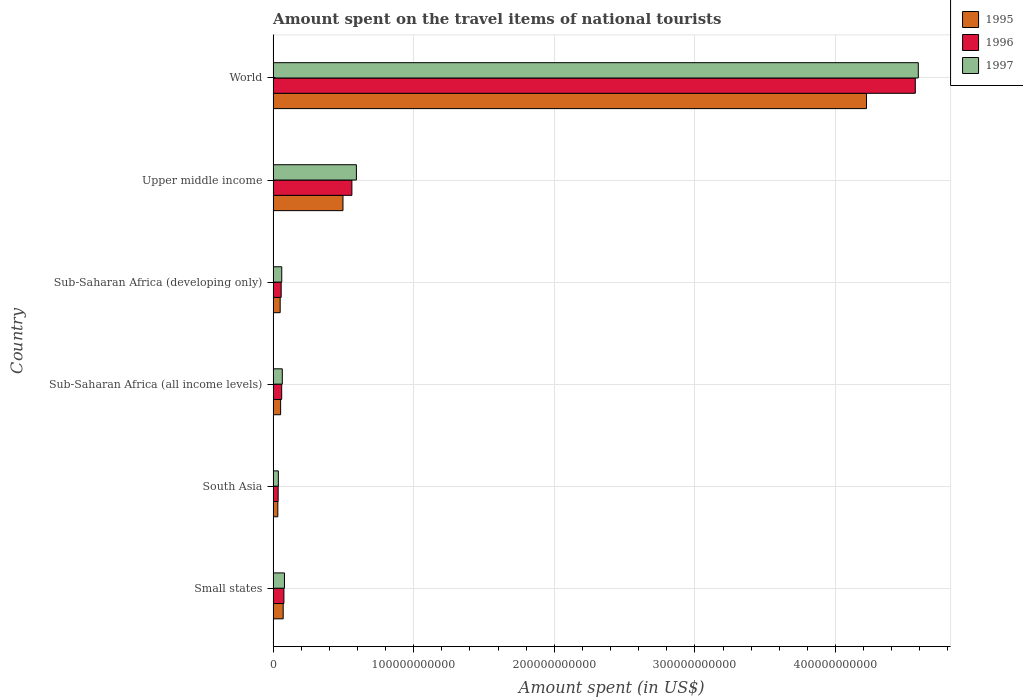How many different coloured bars are there?
Make the answer very short. 3. Are the number of bars per tick equal to the number of legend labels?
Offer a very short reply. Yes. Are the number of bars on each tick of the Y-axis equal?
Your answer should be very brief. Yes. How many bars are there on the 1st tick from the top?
Your answer should be compact. 3. What is the amount spent on the travel items of national tourists in 1995 in Sub-Saharan Africa (all income levels)?
Offer a terse response. 5.34e+09. Across all countries, what is the maximum amount spent on the travel items of national tourists in 1995?
Your answer should be very brief. 4.22e+11. Across all countries, what is the minimum amount spent on the travel items of national tourists in 1996?
Ensure brevity in your answer.  3.58e+09. In which country was the amount spent on the travel items of national tourists in 1996 minimum?
Offer a terse response. South Asia. What is the total amount spent on the travel items of national tourists in 1997 in the graph?
Provide a succinct answer. 5.43e+11. What is the difference between the amount spent on the travel items of national tourists in 1995 in South Asia and that in Sub-Saharan Africa (developing only)?
Give a very brief answer. -1.67e+09. What is the difference between the amount spent on the travel items of national tourists in 1995 in Upper middle income and the amount spent on the travel items of national tourists in 1996 in World?
Provide a succinct answer. -4.07e+11. What is the average amount spent on the travel items of national tourists in 1995 per country?
Offer a terse response. 8.21e+1. What is the difference between the amount spent on the travel items of national tourists in 1995 and amount spent on the travel items of national tourists in 1997 in Sub-Saharan Africa (developing only)?
Offer a terse response. -1.11e+09. In how many countries, is the amount spent on the travel items of national tourists in 1997 greater than 280000000000 US$?
Provide a succinct answer. 1. What is the ratio of the amount spent on the travel items of national tourists in 1996 in South Asia to that in Sub-Saharan Africa (all income levels)?
Provide a succinct answer. 0.59. Is the difference between the amount spent on the travel items of national tourists in 1995 in Sub-Saharan Africa (developing only) and World greater than the difference between the amount spent on the travel items of national tourists in 1997 in Sub-Saharan Africa (developing only) and World?
Your answer should be compact. Yes. What is the difference between the highest and the second highest amount spent on the travel items of national tourists in 1997?
Offer a terse response. 4.00e+11. What is the difference between the highest and the lowest amount spent on the travel items of national tourists in 1996?
Provide a succinct answer. 4.53e+11. In how many countries, is the amount spent on the travel items of national tourists in 1997 greater than the average amount spent on the travel items of national tourists in 1997 taken over all countries?
Offer a terse response. 1. Is the sum of the amount spent on the travel items of national tourists in 1997 in Small states and Upper middle income greater than the maximum amount spent on the travel items of national tourists in 1995 across all countries?
Your answer should be compact. No. What does the 2nd bar from the top in South Asia represents?
Your answer should be compact. 1996. Are all the bars in the graph horizontal?
Your answer should be very brief. Yes. How many countries are there in the graph?
Provide a succinct answer. 6. What is the difference between two consecutive major ticks on the X-axis?
Ensure brevity in your answer.  1.00e+11. Are the values on the major ticks of X-axis written in scientific E-notation?
Your answer should be compact. No. Does the graph contain any zero values?
Your response must be concise. No. Does the graph contain grids?
Your answer should be compact. Yes. How are the legend labels stacked?
Give a very brief answer. Vertical. What is the title of the graph?
Your answer should be very brief. Amount spent on the travel items of national tourists. What is the label or title of the X-axis?
Your response must be concise. Amount spent (in US$). What is the label or title of the Y-axis?
Provide a succinct answer. Country. What is the Amount spent (in US$) in 1995 in Small states?
Offer a terse response. 7.16e+09. What is the Amount spent (in US$) in 1996 in Small states?
Offer a very short reply. 7.67e+09. What is the Amount spent (in US$) in 1997 in Small states?
Ensure brevity in your answer.  8.07e+09. What is the Amount spent (in US$) in 1995 in South Asia?
Your answer should be very brief. 3.35e+09. What is the Amount spent (in US$) of 1996 in South Asia?
Give a very brief answer. 3.58e+09. What is the Amount spent (in US$) of 1997 in South Asia?
Provide a short and direct response. 3.71e+09. What is the Amount spent (in US$) of 1995 in Sub-Saharan Africa (all income levels)?
Offer a terse response. 5.34e+09. What is the Amount spent (in US$) in 1996 in Sub-Saharan Africa (all income levels)?
Make the answer very short. 6.09e+09. What is the Amount spent (in US$) of 1997 in Sub-Saharan Africa (all income levels)?
Make the answer very short. 6.53e+09. What is the Amount spent (in US$) in 1995 in Sub-Saharan Africa (developing only)?
Ensure brevity in your answer.  5.02e+09. What is the Amount spent (in US$) in 1996 in Sub-Saharan Africa (developing only)?
Ensure brevity in your answer.  5.73e+09. What is the Amount spent (in US$) in 1997 in Sub-Saharan Africa (developing only)?
Offer a very short reply. 6.13e+09. What is the Amount spent (in US$) in 1995 in Upper middle income?
Provide a short and direct response. 4.97e+1. What is the Amount spent (in US$) of 1996 in Upper middle income?
Ensure brevity in your answer.  5.60e+1. What is the Amount spent (in US$) of 1997 in Upper middle income?
Ensure brevity in your answer.  5.92e+1. What is the Amount spent (in US$) of 1995 in World?
Ensure brevity in your answer.  4.22e+11. What is the Amount spent (in US$) of 1996 in World?
Keep it short and to the point. 4.57e+11. What is the Amount spent (in US$) in 1997 in World?
Provide a succinct answer. 4.59e+11. Across all countries, what is the maximum Amount spent (in US$) in 1995?
Provide a succinct answer. 4.22e+11. Across all countries, what is the maximum Amount spent (in US$) of 1996?
Provide a succinct answer. 4.57e+11. Across all countries, what is the maximum Amount spent (in US$) of 1997?
Give a very brief answer. 4.59e+11. Across all countries, what is the minimum Amount spent (in US$) in 1995?
Keep it short and to the point. 3.35e+09. Across all countries, what is the minimum Amount spent (in US$) of 1996?
Offer a very short reply. 3.58e+09. Across all countries, what is the minimum Amount spent (in US$) in 1997?
Give a very brief answer. 3.71e+09. What is the total Amount spent (in US$) of 1995 in the graph?
Provide a short and direct response. 4.93e+11. What is the total Amount spent (in US$) of 1996 in the graph?
Offer a terse response. 5.36e+11. What is the total Amount spent (in US$) in 1997 in the graph?
Your answer should be very brief. 5.43e+11. What is the difference between the Amount spent (in US$) in 1995 in Small states and that in South Asia?
Keep it short and to the point. 3.81e+09. What is the difference between the Amount spent (in US$) of 1996 in Small states and that in South Asia?
Offer a terse response. 4.09e+09. What is the difference between the Amount spent (in US$) of 1997 in Small states and that in South Asia?
Give a very brief answer. 4.36e+09. What is the difference between the Amount spent (in US$) in 1995 in Small states and that in Sub-Saharan Africa (all income levels)?
Your answer should be compact. 1.82e+09. What is the difference between the Amount spent (in US$) in 1996 in Small states and that in Sub-Saharan Africa (all income levels)?
Provide a succinct answer. 1.57e+09. What is the difference between the Amount spent (in US$) of 1997 in Small states and that in Sub-Saharan Africa (all income levels)?
Provide a succinct answer. 1.54e+09. What is the difference between the Amount spent (in US$) in 1995 in Small states and that in Sub-Saharan Africa (developing only)?
Ensure brevity in your answer.  2.14e+09. What is the difference between the Amount spent (in US$) in 1996 in Small states and that in Sub-Saharan Africa (developing only)?
Ensure brevity in your answer.  1.93e+09. What is the difference between the Amount spent (in US$) of 1997 in Small states and that in Sub-Saharan Africa (developing only)?
Ensure brevity in your answer.  1.94e+09. What is the difference between the Amount spent (in US$) in 1995 in Small states and that in Upper middle income?
Keep it short and to the point. -4.25e+1. What is the difference between the Amount spent (in US$) of 1996 in Small states and that in Upper middle income?
Offer a very short reply. -4.84e+1. What is the difference between the Amount spent (in US$) of 1997 in Small states and that in Upper middle income?
Your response must be concise. -5.12e+1. What is the difference between the Amount spent (in US$) of 1995 in Small states and that in World?
Your answer should be compact. -4.15e+11. What is the difference between the Amount spent (in US$) in 1996 in Small states and that in World?
Offer a very short reply. -4.49e+11. What is the difference between the Amount spent (in US$) of 1997 in Small states and that in World?
Ensure brevity in your answer.  -4.51e+11. What is the difference between the Amount spent (in US$) of 1995 in South Asia and that in Sub-Saharan Africa (all income levels)?
Provide a succinct answer. -1.99e+09. What is the difference between the Amount spent (in US$) in 1996 in South Asia and that in Sub-Saharan Africa (all income levels)?
Keep it short and to the point. -2.51e+09. What is the difference between the Amount spent (in US$) of 1997 in South Asia and that in Sub-Saharan Africa (all income levels)?
Your answer should be compact. -2.81e+09. What is the difference between the Amount spent (in US$) of 1995 in South Asia and that in Sub-Saharan Africa (developing only)?
Offer a terse response. -1.67e+09. What is the difference between the Amount spent (in US$) in 1996 in South Asia and that in Sub-Saharan Africa (developing only)?
Give a very brief answer. -2.15e+09. What is the difference between the Amount spent (in US$) in 1997 in South Asia and that in Sub-Saharan Africa (developing only)?
Your answer should be compact. -2.42e+09. What is the difference between the Amount spent (in US$) in 1995 in South Asia and that in Upper middle income?
Offer a terse response. -4.63e+1. What is the difference between the Amount spent (in US$) in 1996 in South Asia and that in Upper middle income?
Your response must be concise. -5.24e+1. What is the difference between the Amount spent (in US$) in 1997 in South Asia and that in Upper middle income?
Provide a succinct answer. -5.55e+1. What is the difference between the Amount spent (in US$) in 1995 in South Asia and that in World?
Give a very brief answer. -4.19e+11. What is the difference between the Amount spent (in US$) in 1996 in South Asia and that in World?
Your answer should be very brief. -4.53e+11. What is the difference between the Amount spent (in US$) in 1997 in South Asia and that in World?
Keep it short and to the point. -4.55e+11. What is the difference between the Amount spent (in US$) in 1995 in Sub-Saharan Africa (all income levels) and that in Sub-Saharan Africa (developing only)?
Ensure brevity in your answer.  3.24e+08. What is the difference between the Amount spent (in US$) of 1996 in Sub-Saharan Africa (all income levels) and that in Sub-Saharan Africa (developing only)?
Provide a short and direct response. 3.63e+08. What is the difference between the Amount spent (in US$) of 1997 in Sub-Saharan Africa (all income levels) and that in Sub-Saharan Africa (developing only)?
Offer a terse response. 3.95e+08. What is the difference between the Amount spent (in US$) in 1995 in Sub-Saharan Africa (all income levels) and that in Upper middle income?
Give a very brief answer. -4.43e+1. What is the difference between the Amount spent (in US$) of 1996 in Sub-Saharan Africa (all income levels) and that in Upper middle income?
Provide a succinct answer. -4.99e+1. What is the difference between the Amount spent (in US$) in 1997 in Sub-Saharan Africa (all income levels) and that in Upper middle income?
Your response must be concise. -5.27e+1. What is the difference between the Amount spent (in US$) of 1995 in Sub-Saharan Africa (all income levels) and that in World?
Your answer should be very brief. -4.17e+11. What is the difference between the Amount spent (in US$) of 1996 in Sub-Saharan Africa (all income levels) and that in World?
Offer a terse response. -4.51e+11. What is the difference between the Amount spent (in US$) of 1997 in Sub-Saharan Africa (all income levels) and that in World?
Your response must be concise. -4.52e+11. What is the difference between the Amount spent (in US$) of 1995 in Sub-Saharan Africa (developing only) and that in Upper middle income?
Your answer should be compact. -4.47e+1. What is the difference between the Amount spent (in US$) of 1996 in Sub-Saharan Africa (developing only) and that in Upper middle income?
Provide a succinct answer. -5.03e+1. What is the difference between the Amount spent (in US$) in 1997 in Sub-Saharan Africa (developing only) and that in Upper middle income?
Your answer should be compact. -5.31e+1. What is the difference between the Amount spent (in US$) in 1995 in Sub-Saharan Africa (developing only) and that in World?
Your answer should be compact. -4.17e+11. What is the difference between the Amount spent (in US$) in 1996 in Sub-Saharan Africa (developing only) and that in World?
Your answer should be compact. -4.51e+11. What is the difference between the Amount spent (in US$) in 1997 in Sub-Saharan Africa (developing only) and that in World?
Ensure brevity in your answer.  -4.53e+11. What is the difference between the Amount spent (in US$) in 1995 in Upper middle income and that in World?
Give a very brief answer. -3.72e+11. What is the difference between the Amount spent (in US$) of 1996 in Upper middle income and that in World?
Provide a short and direct response. -4.01e+11. What is the difference between the Amount spent (in US$) in 1997 in Upper middle income and that in World?
Provide a succinct answer. -4.00e+11. What is the difference between the Amount spent (in US$) of 1995 in Small states and the Amount spent (in US$) of 1996 in South Asia?
Your response must be concise. 3.58e+09. What is the difference between the Amount spent (in US$) of 1995 in Small states and the Amount spent (in US$) of 1997 in South Asia?
Provide a short and direct response. 3.45e+09. What is the difference between the Amount spent (in US$) of 1996 in Small states and the Amount spent (in US$) of 1997 in South Asia?
Offer a very short reply. 3.95e+09. What is the difference between the Amount spent (in US$) in 1995 in Small states and the Amount spent (in US$) in 1996 in Sub-Saharan Africa (all income levels)?
Offer a terse response. 1.07e+09. What is the difference between the Amount spent (in US$) in 1995 in Small states and the Amount spent (in US$) in 1997 in Sub-Saharan Africa (all income levels)?
Offer a very short reply. 6.31e+08. What is the difference between the Amount spent (in US$) in 1996 in Small states and the Amount spent (in US$) in 1997 in Sub-Saharan Africa (all income levels)?
Your answer should be compact. 1.14e+09. What is the difference between the Amount spent (in US$) in 1995 in Small states and the Amount spent (in US$) in 1996 in Sub-Saharan Africa (developing only)?
Ensure brevity in your answer.  1.43e+09. What is the difference between the Amount spent (in US$) in 1995 in Small states and the Amount spent (in US$) in 1997 in Sub-Saharan Africa (developing only)?
Provide a short and direct response. 1.03e+09. What is the difference between the Amount spent (in US$) in 1996 in Small states and the Amount spent (in US$) in 1997 in Sub-Saharan Africa (developing only)?
Offer a very short reply. 1.53e+09. What is the difference between the Amount spent (in US$) in 1995 in Small states and the Amount spent (in US$) in 1996 in Upper middle income?
Your answer should be compact. -4.89e+1. What is the difference between the Amount spent (in US$) of 1995 in Small states and the Amount spent (in US$) of 1997 in Upper middle income?
Offer a terse response. -5.21e+1. What is the difference between the Amount spent (in US$) in 1996 in Small states and the Amount spent (in US$) in 1997 in Upper middle income?
Provide a succinct answer. -5.16e+1. What is the difference between the Amount spent (in US$) in 1995 in Small states and the Amount spent (in US$) in 1996 in World?
Provide a short and direct response. -4.50e+11. What is the difference between the Amount spent (in US$) in 1995 in Small states and the Amount spent (in US$) in 1997 in World?
Keep it short and to the point. -4.52e+11. What is the difference between the Amount spent (in US$) in 1996 in Small states and the Amount spent (in US$) in 1997 in World?
Your response must be concise. -4.51e+11. What is the difference between the Amount spent (in US$) in 1995 in South Asia and the Amount spent (in US$) in 1996 in Sub-Saharan Africa (all income levels)?
Provide a short and direct response. -2.75e+09. What is the difference between the Amount spent (in US$) of 1995 in South Asia and the Amount spent (in US$) of 1997 in Sub-Saharan Africa (all income levels)?
Ensure brevity in your answer.  -3.18e+09. What is the difference between the Amount spent (in US$) in 1996 in South Asia and the Amount spent (in US$) in 1997 in Sub-Saharan Africa (all income levels)?
Keep it short and to the point. -2.95e+09. What is the difference between the Amount spent (in US$) in 1995 in South Asia and the Amount spent (in US$) in 1996 in Sub-Saharan Africa (developing only)?
Give a very brief answer. -2.38e+09. What is the difference between the Amount spent (in US$) of 1995 in South Asia and the Amount spent (in US$) of 1997 in Sub-Saharan Africa (developing only)?
Your response must be concise. -2.79e+09. What is the difference between the Amount spent (in US$) in 1996 in South Asia and the Amount spent (in US$) in 1997 in Sub-Saharan Africa (developing only)?
Keep it short and to the point. -2.55e+09. What is the difference between the Amount spent (in US$) in 1995 in South Asia and the Amount spent (in US$) in 1996 in Upper middle income?
Give a very brief answer. -5.27e+1. What is the difference between the Amount spent (in US$) of 1995 in South Asia and the Amount spent (in US$) of 1997 in Upper middle income?
Provide a short and direct response. -5.59e+1. What is the difference between the Amount spent (in US$) in 1996 in South Asia and the Amount spent (in US$) in 1997 in Upper middle income?
Provide a succinct answer. -5.56e+1. What is the difference between the Amount spent (in US$) in 1995 in South Asia and the Amount spent (in US$) in 1996 in World?
Offer a terse response. -4.53e+11. What is the difference between the Amount spent (in US$) in 1995 in South Asia and the Amount spent (in US$) in 1997 in World?
Your response must be concise. -4.56e+11. What is the difference between the Amount spent (in US$) in 1996 in South Asia and the Amount spent (in US$) in 1997 in World?
Give a very brief answer. -4.55e+11. What is the difference between the Amount spent (in US$) of 1995 in Sub-Saharan Africa (all income levels) and the Amount spent (in US$) of 1996 in Sub-Saharan Africa (developing only)?
Your answer should be very brief. -3.89e+08. What is the difference between the Amount spent (in US$) of 1995 in Sub-Saharan Africa (all income levels) and the Amount spent (in US$) of 1997 in Sub-Saharan Africa (developing only)?
Offer a terse response. -7.91e+08. What is the difference between the Amount spent (in US$) in 1996 in Sub-Saharan Africa (all income levels) and the Amount spent (in US$) in 1997 in Sub-Saharan Africa (developing only)?
Your answer should be compact. -3.94e+07. What is the difference between the Amount spent (in US$) in 1995 in Sub-Saharan Africa (all income levels) and the Amount spent (in US$) in 1996 in Upper middle income?
Your answer should be compact. -5.07e+1. What is the difference between the Amount spent (in US$) in 1995 in Sub-Saharan Africa (all income levels) and the Amount spent (in US$) in 1997 in Upper middle income?
Ensure brevity in your answer.  -5.39e+1. What is the difference between the Amount spent (in US$) in 1996 in Sub-Saharan Africa (all income levels) and the Amount spent (in US$) in 1997 in Upper middle income?
Provide a short and direct response. -5.31e+1. What is the difference between the Amount spent (in US$) in 1995 in Sub-Saharan Africa (all income levels) and the Amount spent (in US$) in 1996 in World?
Offer a terse response. -4.51e+11. What is the difference between the Amount spent (in US$) in 1995 in Sub-Saharan Africa (all income levels) and the Amount spent (in US$) in 1997 in World?
Your answer should be very brief. -4.54e+11. What is the difference between the Amount spent (in US$) in 1996 in Sub-Saharan Africa (all income levels) and the Amount spent (in US$) in 1997 in World?
Your answer should be compact. -4.53e+11. What is the difference between the Amount spent (in US$) in 1995 in Sub-Saharan Africa (developing only) and the Amount spent (in US$) in 1996 in Upper middle income?
Make the answer very short. -5.10e+1. What is the difference between the Amount spent (in US$) in 1995 in Sub-Saharan Africa (developing only) and the Amount spent (in US$) in 1997 in Upper middle income?
Ensure brevity in your answer.  -5.42e+1. What is the difference between the Amount spent (in US$) of 1996 in Sub-Saharan Africa (developing only) and the Amount spent (in US$) of 1997 in Upper middle income?
Your answer should be very brief. -5.35e+1. What is the difference between the Amount spent (in US$) in 1995 in Sub-Saharan Africa (developing only) and the Amount spent (in US$) in 1996 in World?
Your response must be concise. -4.52e+11. What is the difference between the Amount spent (in US$) in 1995 in Sub-Saharan Africa (developing only) and the Amount spent (in US$) in 1997 in World?
Offer a very short reply. -4.54e+11. What is the difference between the Amount spent (in US$) of 1996 in Sub-Saharan Africa (developing only) and the Amount spent (in US$) of 1997 in World?
Provide a short and direct response. -4.53e+11. What is the difference between the Amount spent (in US$) of 1995 in Upper middle income and the Amount spent (in US$) of 1996 in World?
Your response must be concise. -4.07e+11. What is the difference between the Amount spent (in US$) in 1995 in Upper middle income and the Amount spent (in US$) in 1997 in World?
Provide a succinct answer. -4.09e+11. What is the difference between the Amount spent (in US$) in 1996 in Upper middle income and the Amount spent (in US$) in 1997 in World?
Ensure brevity in your answer.  -4.03e+11. What is the average Amount spent (in US$) of 1995 per country?
Your answer should be very brief. 8.21e+1. What is the average Amount spent (in US$) of 1996 per country?
Offer a terse response. 8.93e+1. What is the average Amount spent (in US$) in 1997 per country?
Keep it short and to the point. 9.04e+1. What is the difference between the Amount spent (in US$) of 1995 and Amount spent (in US$) of 1996 in Small states?
Your response must be concise. -5.07e+08. What is the difference between the Amount spent (in US$) in 1995 and Amount spent (in US$) in 1997 in Small states?
Your answer should be compact. -9.12e+08. What is the difference between the Amount spent (in US$) in 1996 and Amount spent (in US$) in 1997 in Small states?
Your response must be concise. -4.05e+08. What is the difference between the Amount spent (in US$) in 1995 and Amount spent (in US$) in 1996 in South Asia?
Ensure brevity in your answer.  -2.32e+08. What is the difference between the Amount spent (in US$) in 1995 and Amount spent (in US$) in 1997 in South Asia?
Ensure brevity in your answer.  -3.67e+08. What is the difference between the Amount spent (in US$) of 1996 and Amount spent (in US$) of 1997 in South Asia?
Your answer should be compact. -1.35e+08. What is the difference between the Amount spent (in US$) in 1995 and Amount spent (in US$) in 1996 in Sub-Saharan Africa (all income levels)?
Offer a very short reply. -7.52e+08. What is the difference between the Amount spent (in US$) in 1995 and Amount spent (in US$) in 1997 in Sub-Saharan Africa (all income levels)?
Offer a very short reply. -1.19e+09. What is the difference between the Amount spent (in US$) of 1996 and Amount spent (in US$) of 1997 in Sub-Saharan Africa (all income levels)?
Offer a terse response. -4.34e+08. What is the difference between the Amount spent (in US$) in 1995 and Amount spent (in US$) in 1996 in Sub-Saharan Africa (developing only)?
Keep it short and to the point. -7.13e+08. What is the difference between the Amount spent (in US$) in 1995 and Amount spent (in US$) in 1997 in Sub-Saharan Africa (developing only)?
Keep it short and to the point. -1.11e+09. What is the difference between the Amount spent (in US$) of 1996 and Amount spent (in US$) of 1997 in Sub-Saharan Africa (developing only)?
Offer a very short reply. -4.02e+08. What is the difference between the Amount spent (in US$) in 1995 and Amount spent (in US$) in 1996 in Upper middle income?
Make the answer very short. -6.33e+09. What is the difference between the Amount spent (in US$) in 1995 and Amount spent (in US$) in 1997 in Upper middle income?
Provide a short and direct response. -9.54e+09. What is the difference between the Amount spent (in US$) in 1996 and Amount spent (in US$) in 1997 in Upper middle income?
Provide a short and direct response. -3.21e+09. What is the difference between the Amount spent (in US$) in 1995 and Amount spent (in US$) in 1996 in World?
Your answer should be compact. -3.47e+1. What is the difference between the Amount spent (in US$) in 1995 and Amount spent (in US$) in 1997 in World?
Give a very brief answer. -3.68e+1. What is the difference between the Amount spent (in US$) in 1996 and Amount spent (in US$) in 1997 in World?
Make the answer very short. -2.13e+09. What is the ratio of the Amount spent (in US$) in 1995 in Small states to that in South Asia?
Provide a short and direct response. 2.14. What is the ratio of the Amount spent (in US$) of 1996 in Small states to that in South Asia?
Give a very brief answer. 2.14. What is the ratio of the Amount spent (in US$) of 1997 in Small states to that in South Asia?
Offer a terse response. 2.17. What is the ratio of the Amount spent (in US$) in 1995 in Small states to that in Sub-Saharan Africa (all income levels)?
Ensure brevity in your answer.  1.34. What is the ratio of the Amount spent (in US$) of 1996 in Small states to that in Sub-Saharan Africa (all income levels)?
Provide a succinct answer. 1.26. What is the ratio of the Amount spent (in US$) of 1997 in Small states to that in Sub-Saharan Africa (all income levels)?
Your answer should be compact. 1.24. What is the ratio of the Amount spent (in US$) of 1995 in Small states to that in Sub-Saharan Africa (developing only)?
Your answer should be very brief. 1.43. What is the ratio of the Amount spent (in US$) in 1996 in Small states to that in Sub-Saharan Africa (developing only)?
Your answer should be compact. 1.34. What is the ratio of the Amount spent (in US$) of 1997 in Small states to that in Sub-Saharan Africa (developing only)?
Ensure brevity in your answer.  1.32. What is the ratio of the Amount spent (in US$) of 1995 in Small states to that in Upper middle income?
Provide a short and direct response. 0.14. What is the ratio of the Amount spent (in US$) in 1996 in Small states to that in Upper middle income?
Make the answer very short. 0.14. What is the ratio of the Amount spent (in US$) of 1997 in Small states to that in Upper middle income?
Ensure brevity in your answer.  0.14. What is the ratio of the Amount spent (in US$) in 1995 in Small states to that in World?
Your answer should be very brief. 0.02. What is the ratio of the Amount spent (in US$) in 1996 in Small states to that in World?
Make the answer very short. 0.02. What is the ratio of the Amount spent (in US$) of 1997 in Small states to that in World?
Offer a terse response. 0.02. What is the ratio of the Amount spent (in US$) of 1995 in South Asia to that in Sub-Saharan Africa (all income levels)?
Offer a terse response. 0.63. What is the ratio of the Amount spent (in US$) in 1996 in South Asia to that in Sub-Saharan Africa (all income levels)?
Make the answer very short. 0.59. What is the ratio of the Amount spent (in US$) in 1997 in South Asia to that in Sub-Saharan Africa (all income levels)?
Make the answer very short. 0.57. What is the ratio of the Amount spent (in US$) in 1995 in South Asia to that in Sub-Saharan Africa (developing only)?
Your answer should be very brief. 0.67. What is the ratio of the Amount spent (in US$) of 1996 in South Asia to that in Sub-Saharan Africa (developing only)?
Offer a terse response. 0.62. What is the ratio of the Amount spent (in US$) of 1997 in South Asia to that in Sub-Saharan Africa (developing only)?
Provide a short and direct response. 0.61. What is the ratio of the Amount spent (in US$) in 1995 in South Asia to that in Upper middle income?
Your answer should be very brief. 0.07. What is the ratio of the Amount spent (in US$) of 1996 in South Asia to that in Upper middle income?
Offer a very short reply. 0.06. What is the ratio of the Amount spent (in US$) in 1997 in South Asia to that in Upper middle income?
Make the answer very short. 0.06. What is the ratio of the Amount spent (in US$) of 1995 in South Asia to that in World?
Provide a succinct answer. 0.01. What is the ratio of the Amount spent (in US$) in 1996 in South Asia to that in World?
Offer a very short reply. 0.01. What is the ratio of the Amount spent (in US$) of 1997 in South Asia to that in World?
Give a very brief answer. 0.01. What is the ratio of the Amount spent (in US$) of 1995 in Sub-Saharan Africa (all income levels) to that in Sub-Saharan Africa (developing only)?
Provide a succinct answer. 1.06. What is the ratio of the Amount spent (in US$) of 1996 in Sub-Saharan Africa (all income levels) to that in Sub-Saharan Africa (developing only)?
Provide a short and direct response. 1.06. What is the ratio of the Amount spent (in US$) in 1997 in Sub-Saharan Africa (all income levels) to that in Sub-Saharan Africa (developing only)?
Provide a short and direct response. 1.06. What is the ratio of the Amount spent (in US$) of 1995 in Sub-Saharan Africa (all income levels) to that in Upper middle income?
Ensure brevity in your answer.  0.11. What is the ratio of the Amount spent (in US$) in 1996 in Sub-Saharan Africa (all income levels) to that in Upper middle income?
Your response must be concise. 0.11. What is the ratio of the Amount spent (in US$) of 1997 in Sub-Saharan Africa (all income levels) to that in Upper middle income?
Ensure brevity in your answer.  0.11. What is the ratio of the Amount spent (in US$) in 1995 in Sub-Saharan Africa (all income levels) to that in World?
Offer a terse response. 0.01. What is the ratio of the Amount spent (in US$) of 1996 in Sub-Saharan Africa (all income levels) to that in World?
Give a very brief answer. 0.01. What is the ratio of the Amount spent (in US$) of 1997 in Sub-Saharan Africa (all income levels) to that in World?
Ensure brevity in your answer.  0.01. What is the ratio of the Amount spent (in US$) of 1995 in Sub-Saharan Africa (developing only) to that in Upper middle income?
Offer a terse response. 0.1. What is the ratio of the Amount spent (in US$) in 1996 in Sub-Saharan Africa (developing only) to that in Upper middle income?
Your response must be concise. 0.1. What is the ratio of the Amount spent (in US$) in 1997 in Sub-Saharan Africa (developing only) to that in Upper middle income?
Make the answer very short. 0.1. What is the ratio of the Amount spent (in US$) in 1995 in Sub-Saharan Africa (developing only) to that in World?
Make the answer very short. 0.01. What is the ratio of the Amount spent (in US$) in 1996 in Sub-Saharan Africa (developing only) to that in World?
Keep it short and to the point. 0.01. What is the ratio of the Amount spent (in US$) of 1997 in Sub-Saharan Africa (developing only) to that in World?
Offer a very short reply. 0.01. What is the ratio of the Amount spent (in US$) in 1995 in Upper middle income to that in World?
Your answer should be very brief. 0.12. What is the ratio of the Amount spent (in US$) of 1996 in Upper middle income to that in World?
Give a very brief answer. 0.12. What is the ratio of the Amount spent (in US$) in 1997 in Upper middle income to that in World?
Give a very brief answer. 0.13. What is the difference between the highest and the second highest Amount spent (in US$) of 1995?
Ensure brevity in your answer.  3.72e+11. What is the difference between the highest and the second highest Amount spent (in US$) of 1996?
Make the answer very short. 4.01e+11. What is the difference between the highest and the second highest Amount spent (in US$) of 1997?
Provide a short and direct response. 4.00e+11. What is the difference between the highest and the lowest Amount spent (in US$) in 1995?
Give a very brief answer. 4.19e+11. What is the difference between the highest and the lowest Amount spent (in US$) of 1996?
Your answer should be compact. 4.53e+11. What is the difference between the highest and the lowest Amount spent (in US$) in 1997?
Keep it short and to the point. 4.55e+11. 